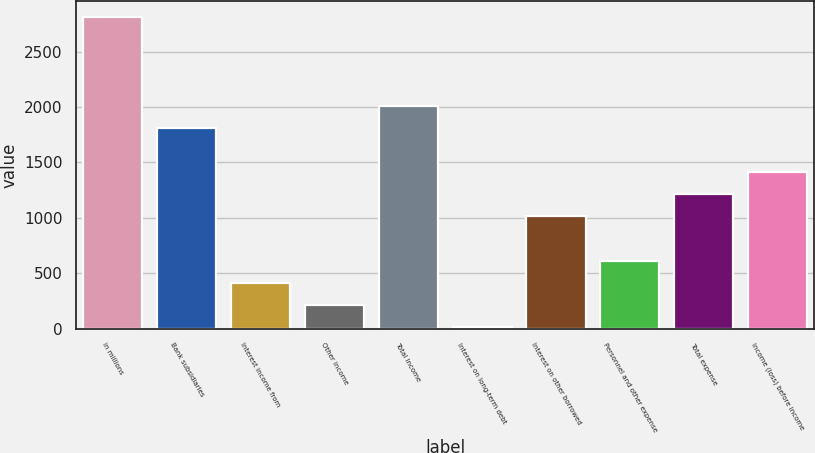<chart> <loc_0><loc_0><loc_500><loc_500><bar_chart><fcel>in millions<fcel>Bank subsidiaries<fcel>Interest income from<fcel>Other income<fcel>Total income<fcel>Interest on long-term debt<fcel>Interest on other borrowed<fcel>Personnel and other expense<fcel>Total expense<fcel>Income (loss) before income<nl><fcel>2815.6<fcel>1813.6<fcel>410.8<fcel>210.4<fcel>2014<fcel>10<fcel>1012<fcel>611.2<fcel>1212.4<fcel>1412.8<nl></chart> 